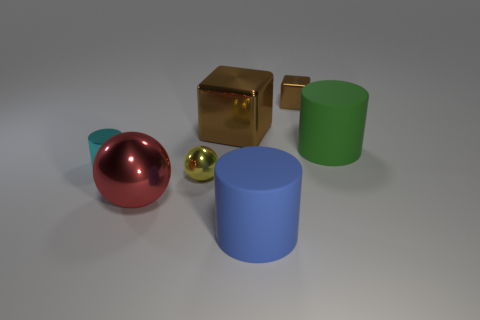How many objects are either objects that are in front of the yellow metallic thing or tiny metallic objects that are behind the yellow shiny ball?
Keep it short and to the point. 4. There is another small thing that is the same shape as the blue matte object; what material is it?
Your answer should be very brief. Metal. Is there a tiny yellow sphere?
Give a very brief answer. Yes. What is the size of the cylinder that is to the right of the big brown shiny block and to the left of the tiny brown metal block?
Give a very brief answer. Large. What is the shape of the red metal object?
Ensure brevity in your answer.  Sphere. There is a big cylinder on the left side of the green rubber cylinder; are there any tiny brown metal cubes in front of it?
Ensure brevity in your answer.  No. There is a brown thing that is the same size as the metal cylinder; what material is it?
Offer a terse response. Metal. Are there any cyan things of the same size as the blue matte cylinder?
Give a very brief answer. No. What is the ball that is in front of the tiny yellow ball made of?
Make the answer very short. Metal. Is the material of the big cylinder that is in front of the green rubber object the same as the large brown cube?
Make the answer very short. No. 